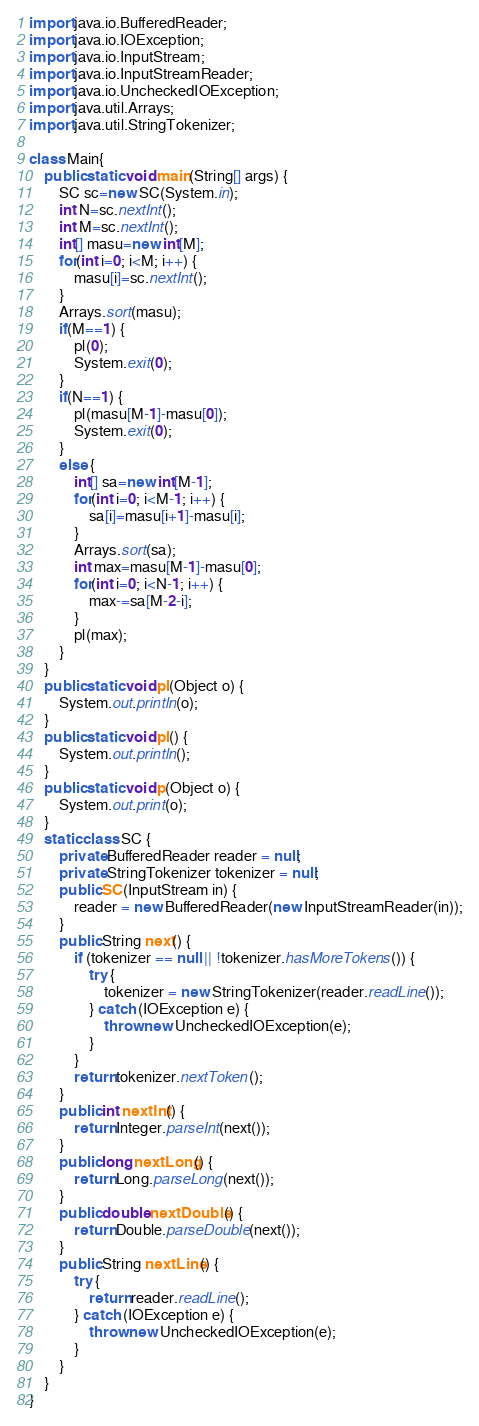<code> <loc_0><loc_0><loc_500><loc_500><_Java_>import java.io.BufferedReader;
import java.io.IOException;
import java.io.InputStream;
import java.io.InputStreamReader;
import java.io.UncheckedIOException;
import java.util.Arrays;
import java.util.StringTokenizer;

class Main{
	public static void main(String[] args) {
		SC sc=new SC(System.in);
		int N=sc.nextInt();
		int M=sc.nextInt();
		int[] masu=new int[M];
		for(int i=0; i<M; i++) {
			masu[i]=sc.nextInt();
		}
		Arrays.sort(masu);
		if(M==1) {
			pl(0);
			System.exit(0);
		}
		if(N==1) {
			pl(masu[M-1]-masu[0]);
			System.exit(0);
		}
		else {
			int[] sa=new int[M-1];
			for(int i=0; i<M-1; i++) {
				sa[i]=masu[i+1]-masu[i];
			}
			Arrays.sort(sa);
			int max=masu[M-1]-masu[0];
			for(int i=0; i<N-1; i++) {
				max-=sa[M-2-i];
			}
			pl(max);
		}
	}
	public static void pl(Object o) {
		System.out.println(o);
	}
	public static void pl() {
		System.out.println();
	}
	public static void p(Object o) {
		System.out.print(o);
	}
	static class SC {
		private BufferedReader reader = null;
		private StringTokenizer tokenizer = null;
		public SC(InputStream in) {
			reader = new BufferedReader(new InputStreamReader(in));
		}
		public String next() {
			if (tokenizer == null || !tokenizer.hasMoreTokens()) {
				try {
					tokenizer = new StringTokenizer(reader.readLine());
				} catch (IOException e) {
					throw new UncheckedIOException(e);
				}
			}
			return tokenizer.nextToken();
		}
		public int nextInt() {
			return Integer.parseInt(next());
		}
		public long nextLong() {
			return Long.parseLong(next());
		}
		public double nextDouble() {
			return Double.parseDouble(next());
		}
		public String nextLine() {
			try {
				return reader.readLine();
			} catch (IOException e) {
				throw new UncheckedIOException(e);
			}
		}
	}
}</code> 